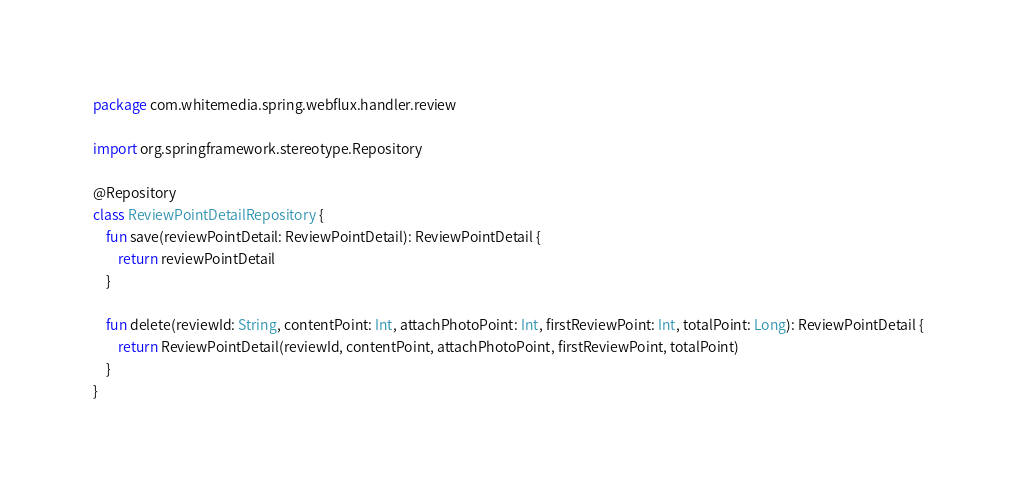Convert code to text. <code><loc_0><loc_0><loc_500><loc_500><_Kotlin_>package com.whitemedia.spring.webflux.handler.review

import org.springframework.stereotype.Repository

@Repository
class ReviewPointDetailRepository {
    fun save(reviewPointDetail: ReviewPointDetail): ReviewPointDetail {
        return reviewPointDetail
    }

    fun delete(reviewId: String, contentPoint: Int, attachPhotoPoint: Int, firstReviewPoint: Int, totalPoint: Long): ReviewPointDetail {
        return ReviewPointDetail(reviewId, contentPoint, attachPhotoPoint, firstReviewPoint, totalPoint)
    }
}
</code> 